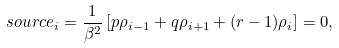<formula> <loc_0><loc_0><loc_500><loc_500>\ s o u r c e _ { i } = \frac { 1 } { \beta ^ { 2 } } \left [ p \rho _ { i - 1 } + q \rho _ { i + 1 } + ( r - 1 ) \rho _ { i } \right ] = 0 ,</formula> 